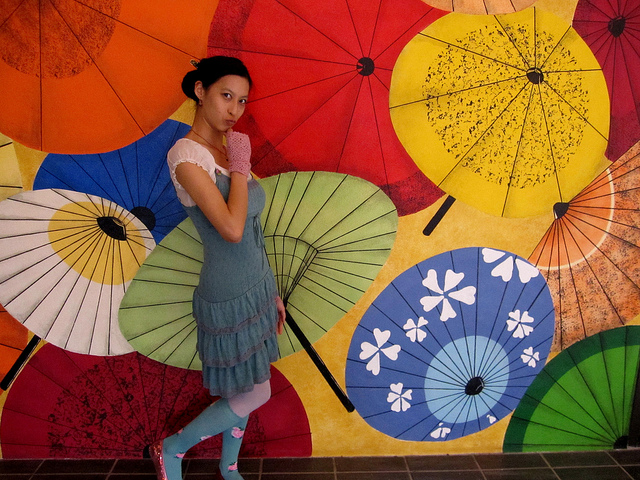<image>What is her name? It's unanswerable what her name is. It could be any of the mentioned names like 'april', 'jackie', 'amy', 'lily', 'melissa', 'olivia', 'allison', 'rachel' or 'anna'. How tall is she? It is ambiguous to tell how tall she is without referencing the image. What is her name? I don't know her name. It can be April, Jackie, Amy, Lily, Melissa, Olivia, Allison, Rachel or Anna. How tall is she? I don't know how tall she is. It can be any height from 5'2" to 5'6". 